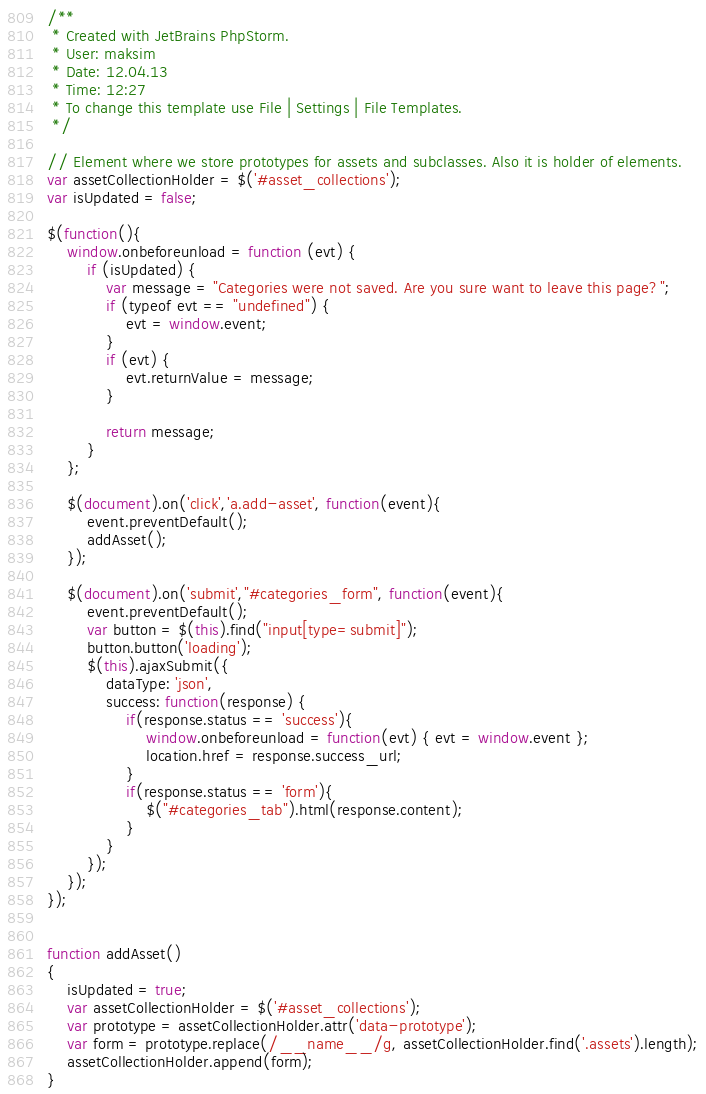<code> <loc_0><loc_0><loc_500><loc_500><_JavaScript_>/**
 * Created with JetBrains PhpStorm.
 * User: maksim
 * Date: 12.04.13
 * Time: 12:27
 * To change this template use File | Settings | File Templates.
 */

// Element where we store prototypes for assets and subclasses. Also it is holder of elements.
var assetCollectionHolder = $('#asset_collections');
var isUpdated = false;

$(function(){
    window.onbeforeunload = function (evt) {
        if (isUpdated) {
            var message = "Categories were not saved. Are you sure want to leave this page?";
            if (typeof evt == "undefined") {
                evt = window.event;
            }
            if (evt) {
                evt.returnValue = message;
            }

            return message;
        }
    };

    $(document).on('click','a.add-asset', function(event){
        event.preventDefault();
        addAsset();
    });

    $(document).on('submit',"#categories_form", function(event){
        event.preventDefault();
        var button = $(this).find("input[type=submit]");
        button.button('loading');
        $(this).ajaxSubmit({
            dataType: 'json',
            success: function(response) {
                if(response.status == 'success'){
                    window.onbeforeunload = function(evt) { evt = window.event };
                    location.href = response.success_url;
                }
                if(response.status == 'form'){
                    $("#categories_tab").html(response.content);
                }
            }
        });
    });
});


function addAsset()
{
    isUpdated = true;
    var assetCollectionHolder = $('#asset_collections');
    var prototype = assetCollectionHolder.attr('data-prototype');
    var form = prototype.replace(/__name__/g, assetCollectionHolder.find('.assets').length);
    assetCollectionHolder.append(form);
}
</code> 